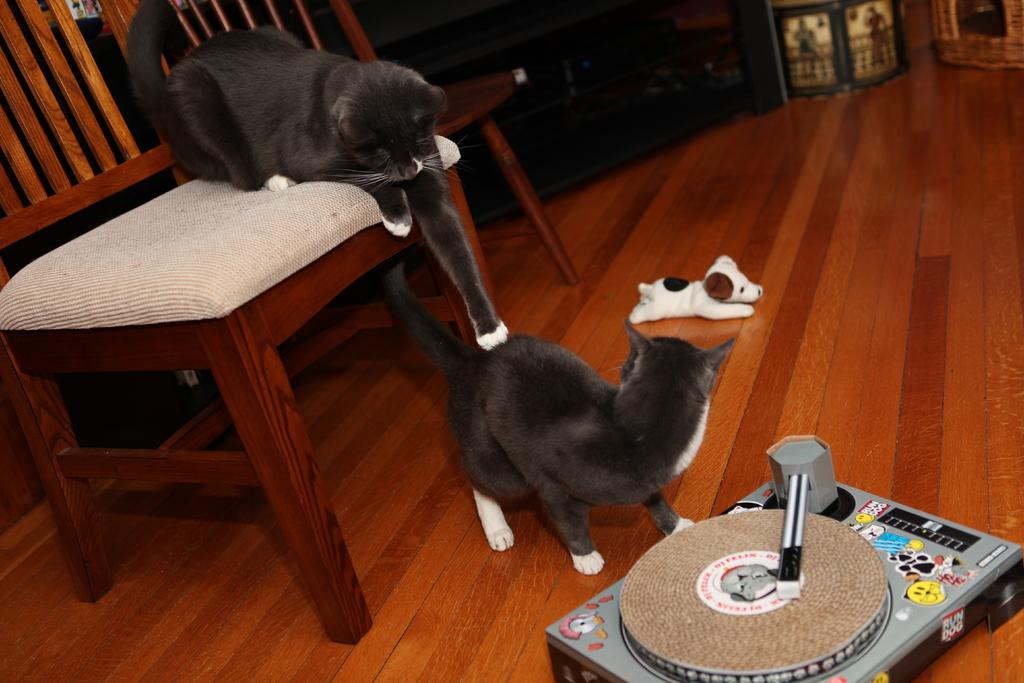How many cats are in the image? There are two cats in the image. Where is one of the cats located? One cat is on a chair. Where is the other cat located? The other cat is on the floor. What other object can be seen in the image? There is there a dog toy in the image. What device is present in the image? There is a tape recorder in the image. What is visible in the background of the image? There is a wall in the image. What type of apples are being used as a decoration on the wall in the image? There are no apples present in the image; the wall is not decorated with apples. 